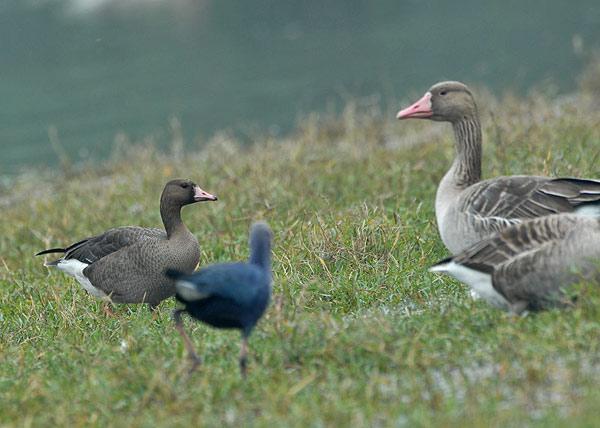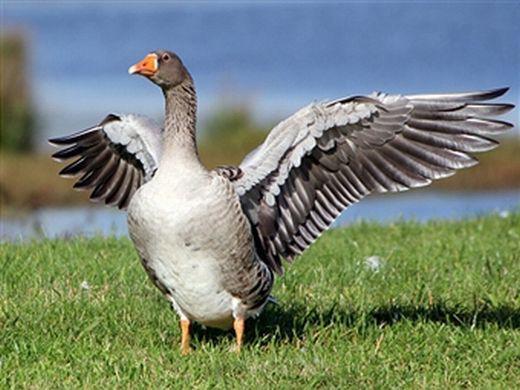The first image is the image on the left, the second image is the image on the right. Examine the images to the left and right. Is the description "The right image shows ducks with multiple ducklings." accurate? Answer yes or no. No. 